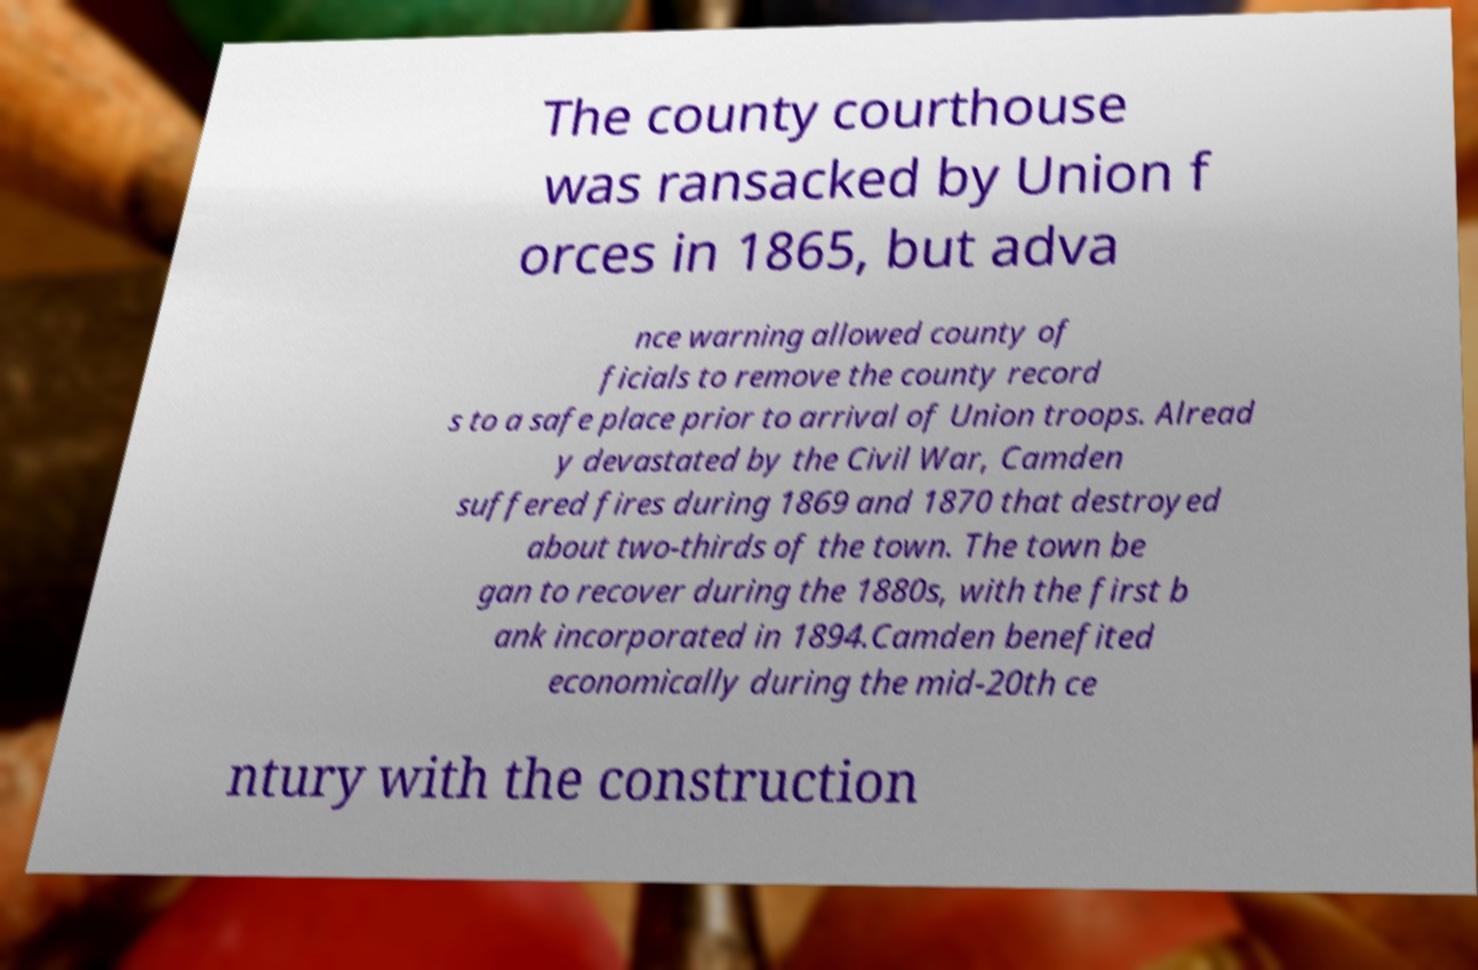What messages or text are displayed in this image? I need them in a readable, typed format. The county courthouse was ransacked by Union f orces in 1865, but adva nce warning allowed county of ficials to remove the county record s to a safe place prior to arrival of Union troops. Alread y devastated by the Civil War, Camden suffered fires during 1869 and 1870 that destroyed about two-thirds of the town. The town be gan to recover during the 1880s, with the first b ank incorporated in 1894.Camden benefited economically during the mid-20th ce ntury with the construction 